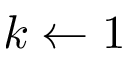Convert formula to latex. <formula><loc_0><loc_0><loc_500><loc_500>k \leftarrow 1</formula> 